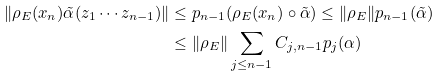<formula> <loc_0><loc_0><loc_500><loc_500>\| \rho _ { E } ( x _ { n } ) \tilde { \alpha } ( z _ { 1 } \cdots z _ { n - 1 } ) \| & \leq p _ { n - 1 } ( \rho _ { E } ( x _ { n } ) \circ \tilde { \alpha } ) \leq \| \rho _ { E } \| p _ { n - 1 } ( \tilde { \alpha } ) \\ & \leq \| \rho _ { E } \| \sum _ { j \leq n - 1 } C _ { j , n - 1 } p _ { j } ( \alpha )</formula> 